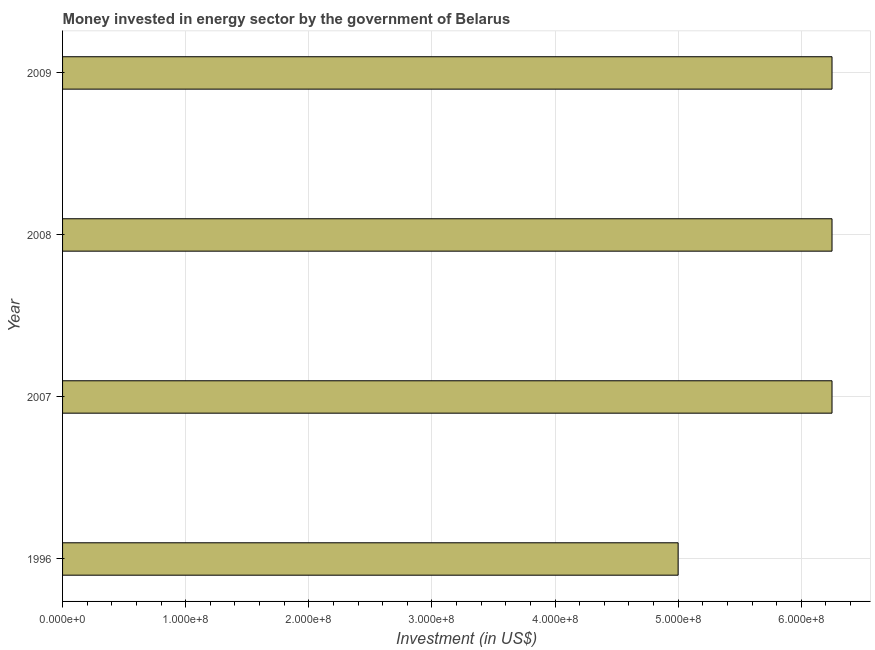Does the graph contain any zero values?
Offer a very short reply. No. Does the graph contain grids?
Your answer should be very brief. Yes. What is the title of the graph?
Provide a succinct answer. Money invested in energy sector by the government of Belarus. What is the label or title of the X-axis?
Your response must be concise. Investment (in US$). What is the investment in energy in 2007?
Make the answer very short. 6.25e+08. Across all years, what is the maximum investment in energy?
Keep it short and to the point. 6.25e+08. In which year was the investment in energy maximum?
Keep it short and to the point. 2007. In which year was the investment in energy minimum?
Your answer should be very brief. 1996. What is the sum of the investment in energy?
Ensure brevity in your answer.  2.38e+09. What is the difference between the investment in energy in 1996 and 2008?
Your answer should be compact. -1.25e+08. What is the average investment in energy per year?
Offer a very short reply. 5.94e+08. What is the median investment in energy?
Provide a short and direct response. 6.25e+08. What is the ratio of the investment in energy in 2008 to that in 2009?
Give a very brief answer. 1. Is the investment in energy in 2007 less than that in 2008?
Provide a short and direct response. No. Is the difference between the investment in energy in 1996 and 2009 greater than the difference between any two years?
Offer a terse response. Yes. Is the sum of the investment in energy in 1996 and 2009 greater than the maximum investment in energy across all years?
Your answer should be compact. Yes. What is the difference between the highest and the lowest investment in energy?
Ensure brevity in your answer.  1.25e+08. How many bars are there?
Your response must be concise. 4. How many years are there in the graph?
Your answer should be very brief. 4. What is the difference between two consecutive major ticks on the X-axis?
Your answer should be compact. 1.00e+08. Are the values on the major ticks of X-axis written in scientific E-notation?
Give a very brief answer. Yes. What is the Investment (in US$) of 1996?
Make the answer very short. 5.00e+08. What is the Investment (in US$) in 2007?
Give a very brief answer. 6.25e+08. What is the Investment (in US$) in 2008?
Provide a succinct answer. 6.25e+08. What is the Investment (in US$) in 2009?
Make the answer very short. 6.25e+08. What is the difference between the Investment (in US$) in 1996 and 2007?
Your answer should be very brief. -1.25e+08. What is the difference between the Investment (in US$) in 1996 and 2008?
Your response must be concise. -1.25e+08. What is the difference between the Investment (in US$) in 1996 and 2009?
Give a very brief answer. -1.25e+08. What is the difference between the Investment (in US$) in 2007 and 2008?
Your response must be concise. 0. What is the ratio of the Investment (in US$) in 2008 to that in 2009?
Provide a succinct answer. 1. 